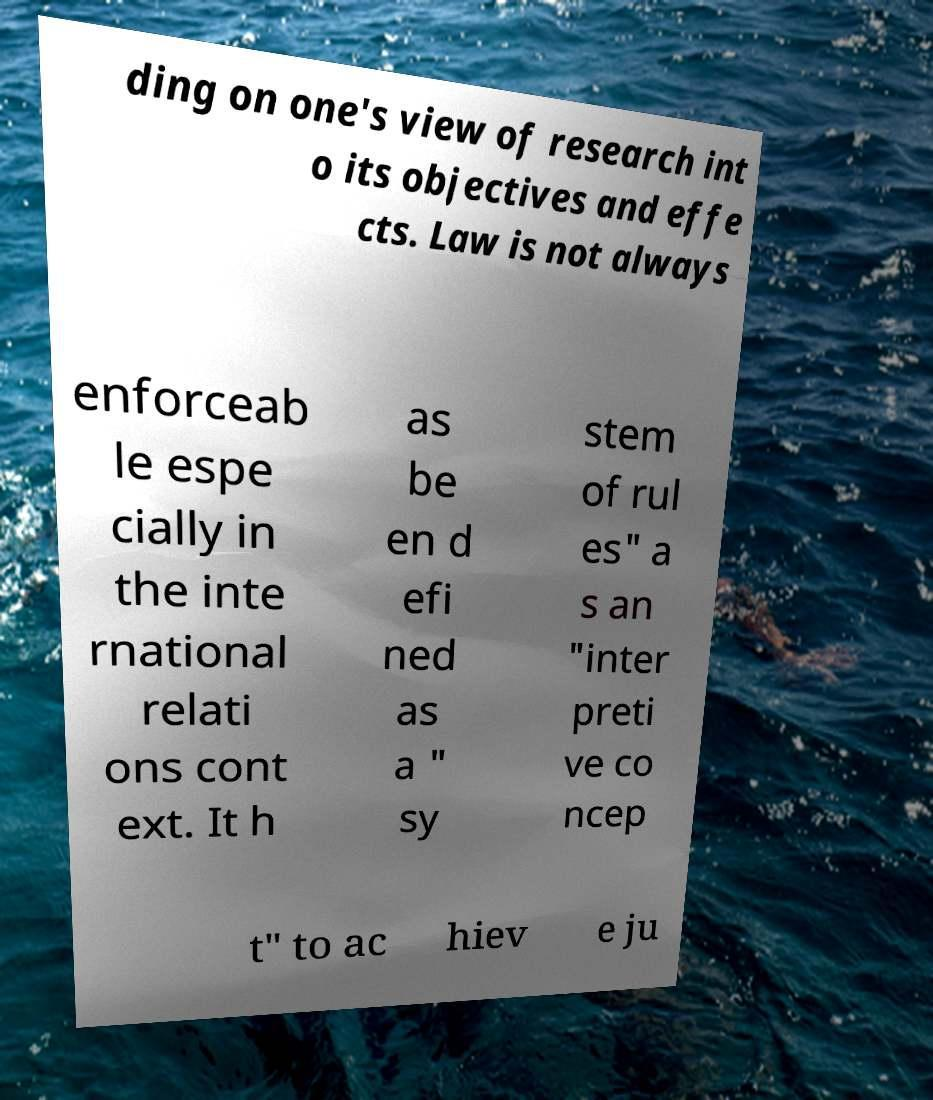Can you accurately transcribe the text from the provided image for me? ding on one's view of research int o its objectives and effe cts. Law is not always enforceab le espe cially in the inte rnational relati ons cont ext. It h as be en d efi ned as a " sy stem of rul es" a s an "inter preti ve co ncep t" to ac hiev e ju 